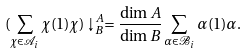<formula> <loc_0><loc_0><loc_500><loc_500>( \sum _ { \chi \in \mathcal { A } _ { i } } \chi ( 1 ) \chi ) \downarrow _ { B } ^ { A } = \frac { \dim A } { \dim B } \sum _ { \alpha \in \mathcal { B } _ { i } } \alpha ( 1 ) \alpha .</formula> 